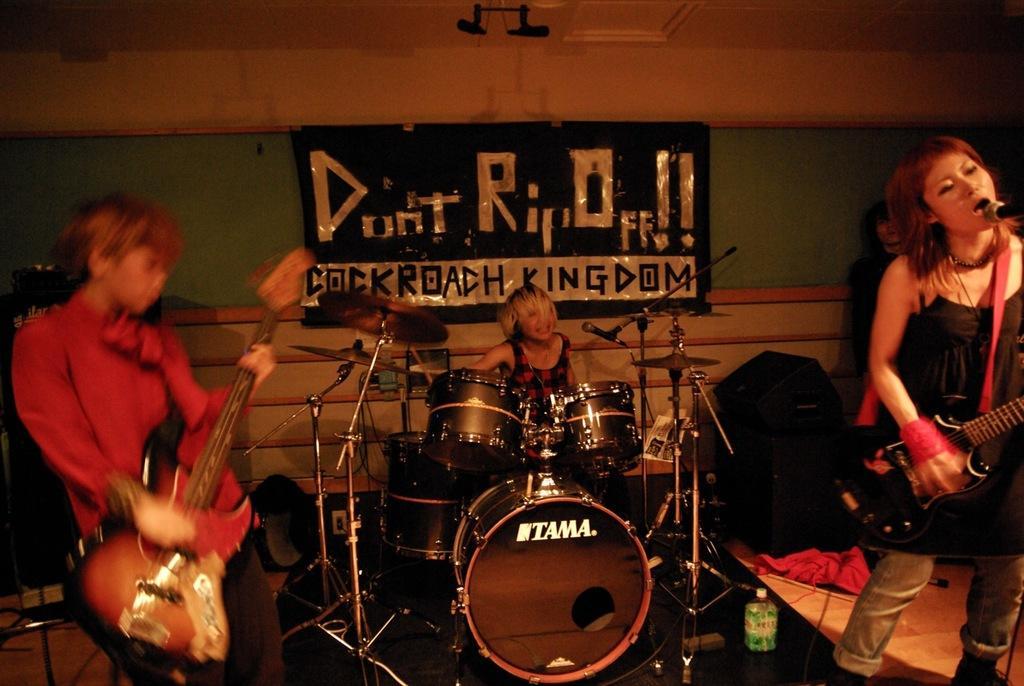How would you summarize this image in a sentence or two? As we can see in the image there is a wall, banner, few people here and there, musical drums and guitars. 